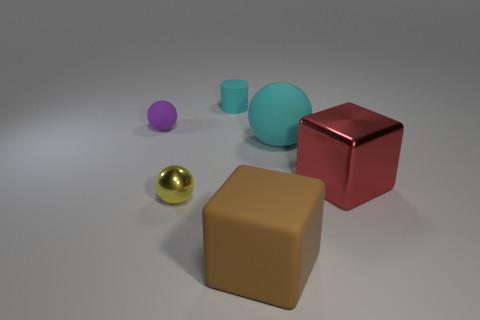What is the material of the large object that is the same color as the matte cylinder?
Give a very brief answer. Rubber. What number of matte things are either cyan things or small cylinders?
Offer a terse response. 2. The brown thing has what shape?
Offer a terse response. Cube. How many yellow balls have the same material as the brown object?
Your answer should be very brief. 0. The cylinder that is made of the same material as the brown object is what color?
Keep it short and to the point. Cyan. There is a sphere that is in front of the cyan rubber ball; is its size the same as the large rubber cube?
Offer a very short reply. No. There is another thing that is the same shape as the large red metal object; what color is it?
Your answer should be compact. Brown. There is a thing that is to the left of the metal thing to the left of the large matte thing in front of the large sphere; what is its shape?
Provide a short and direct response. Sphere. Does the small yellow metallic object have the same shape as the tiny purple rubber object?
Offer a terse response. Yes. What is the shape of the cyan object behind the rubber thing on the left side of the yellow object?
Offer a terse response. Cylinder. 